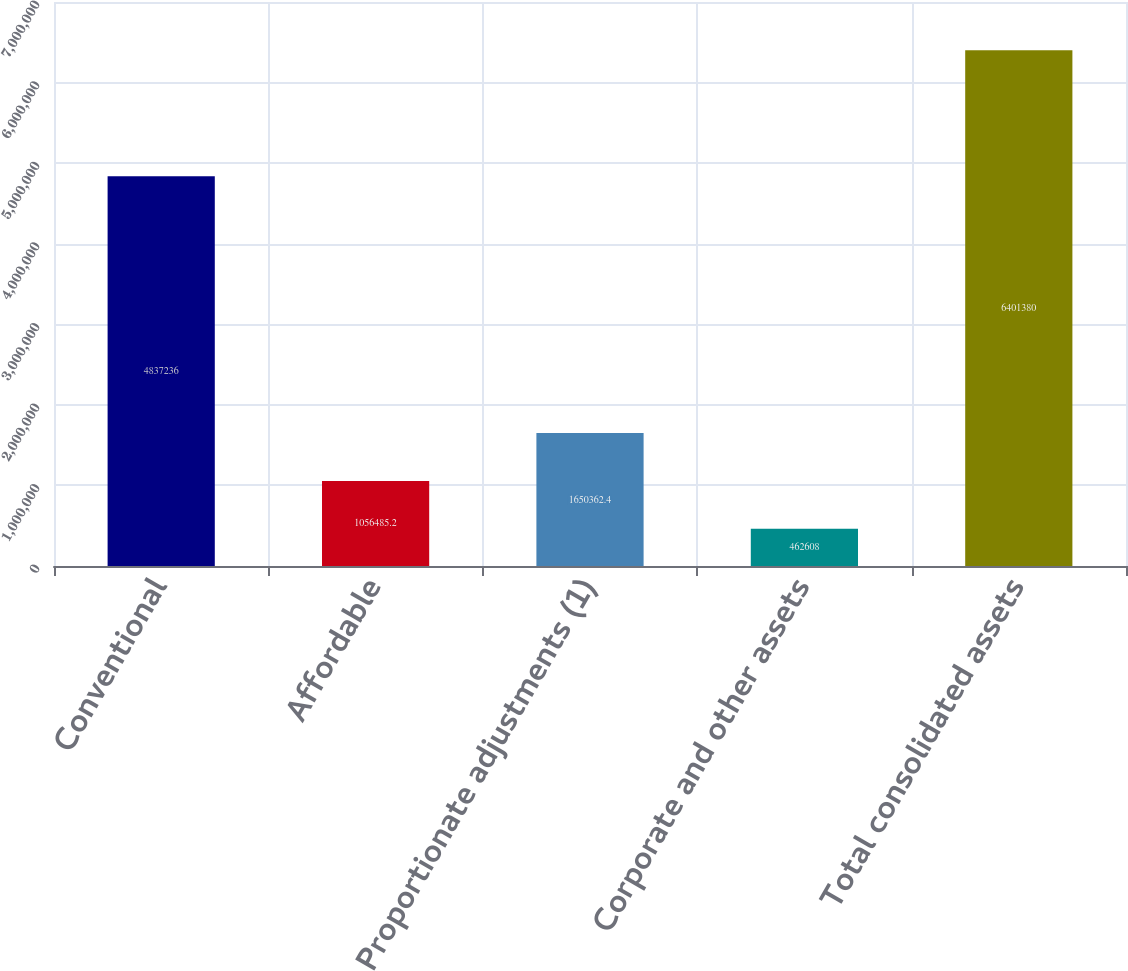Convert chart to OTSL. <chart><loc_0><loc_0><loc_500><loc_500><bar_chart><fcel>Conventional<fcel>Affordable<fcel>Proportionate adjustments (1)<fcel>Corporate and other assets<fcel>Total consolidated assets<nl><fcel>4.83724e+06<fcel>1.05649e+06<fcel>1.65036e+06<fcel>462608<fcel>6.40138e+06<nl></chart> 